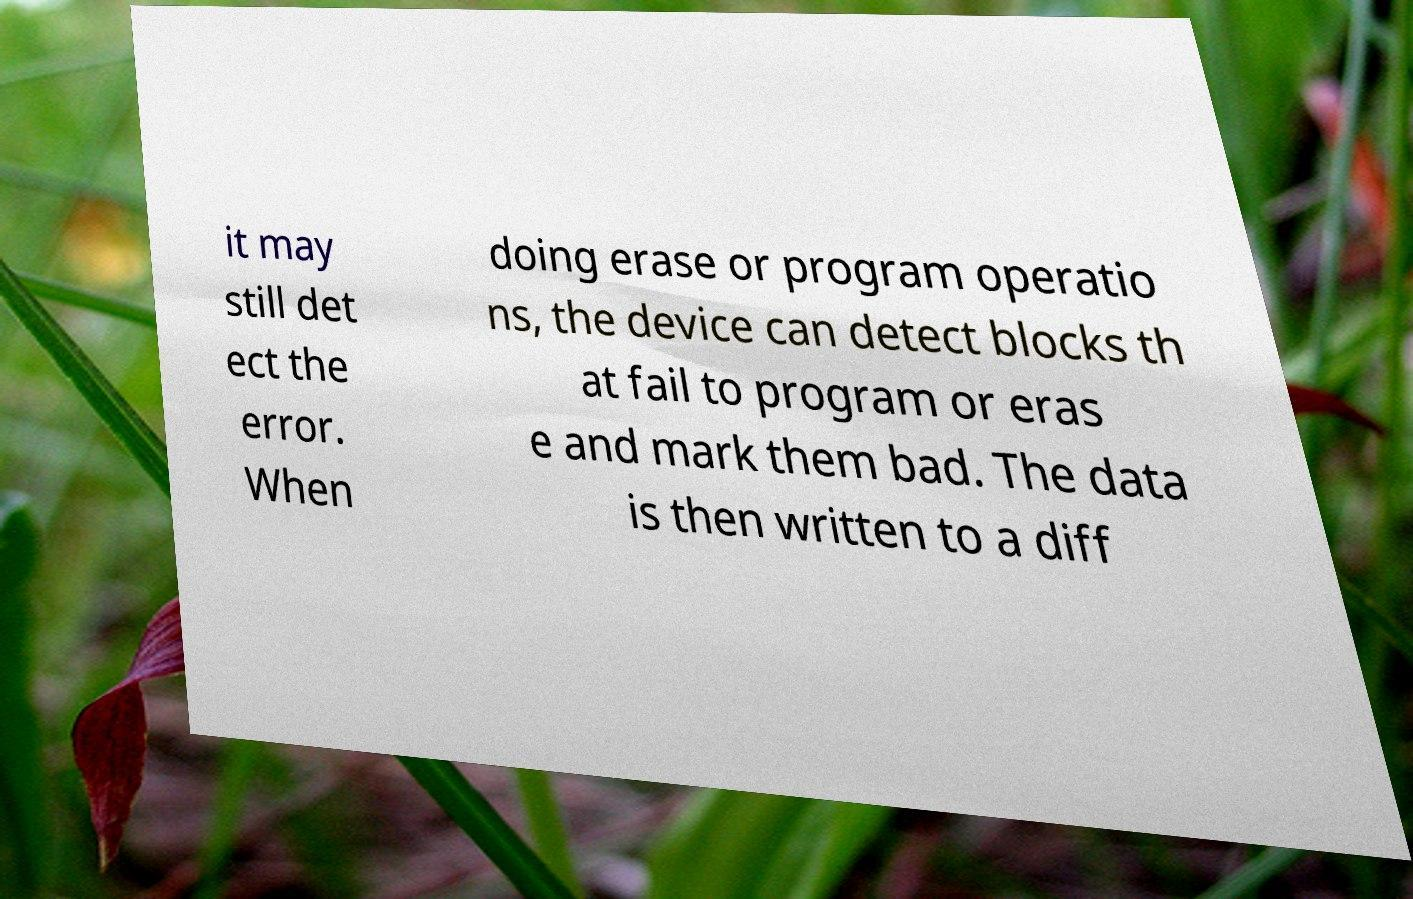I need the written content from this picture converted into text. Can you do that? it may still det ect the error. When doing erase or program operatio ns, the device can detect blocks th at fail to program or eras e and mark them bad. The data is then written to a diff 